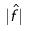Convert formula to latex. <formula><loc_0><loc_0><loc_500><loc_500>| \hat { f } |</formula> 